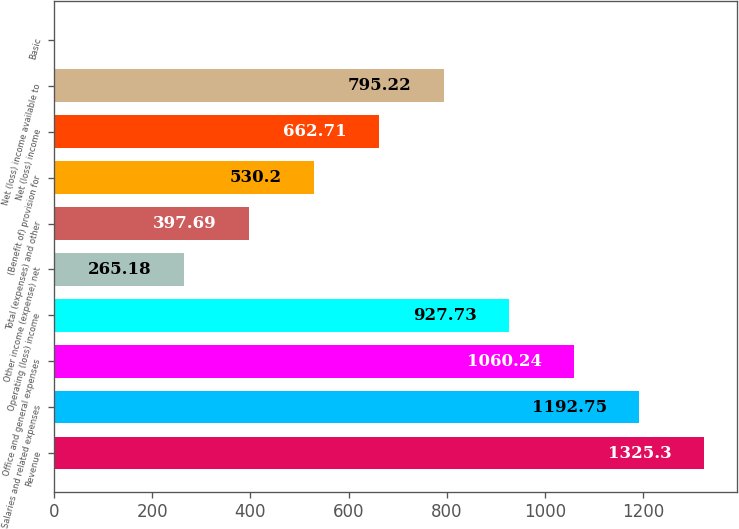Convert chart to OTSL. <chart><loc_0><loc_0><loc_500><loc_500><bar_chart><fcel>Revenue<fcel>Salaries and related expenses<fcel>Office and general expenses<fcel>Operating (loss) income<fcel>Other income (expense) net<fcel>Total (expenses) and other<fcel>(Benefit of) provision for<fcel>Net (loss) income<fcel>Net (loss) income available to<fcel>Basic<nl><fcel>1325.3<fcel>1192.75<fcel>1060.24<fcel>927.73<fcel>265.18<fcel>397.69<fcel>530.2<fcel>662.71<fcel>795.22<fcel>0.16<nl></chart> 